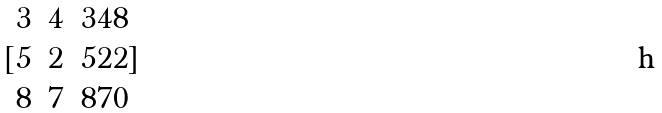<formula> <loc_0><loc_0><loc_500><loc_500>[ \begin{matrix} 3 & 4 & 3 4 8 \\ 5 & 2 & 5 2 2 \\ 8 & 7 & 8 7 0 \end{matrix} ]</formula> 